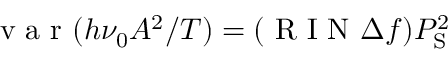<formula> <loc_0><loc_0><loc_500><loc_500>v a r ( h \nu _ { 0 } A ^ { 2 } / T ) = ( R I N \Delta f ) P _ { S } ^ { 2 }</formula> 